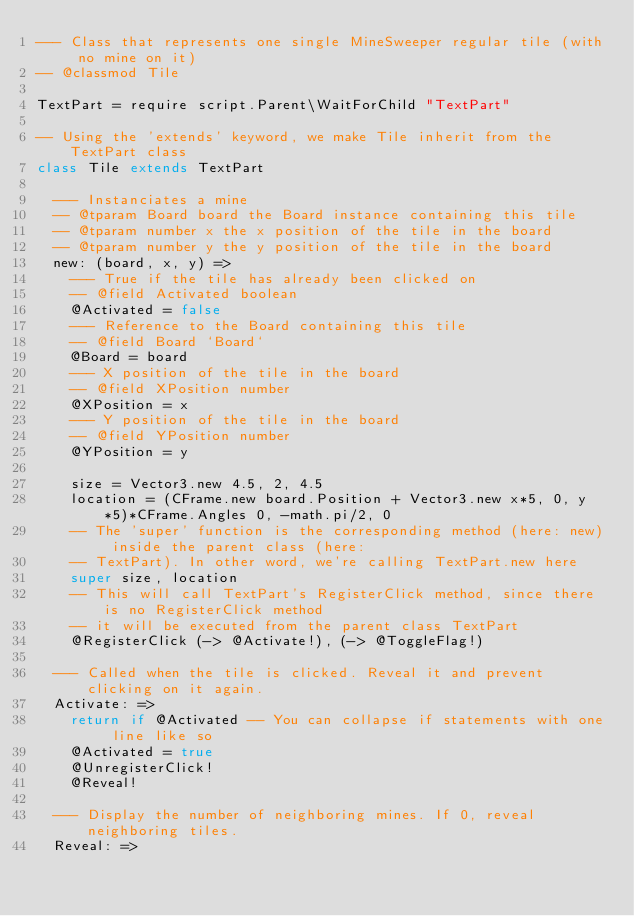<code> <loc_0><loc_0><loc_500><loc_500><_MoonScript_>--- Class that represents one single MineSweeper regular tile (with no mine on it)
-- @classmod Tile

TextPart = require script.Parent\WaitForChild "TextPart"

-- Using the 'extends' keyword, we make Tile inherit from the TextPart class
class Tile extends TextPart

  --- Instanciates a mine
  -- @tparam Board board the Board instance containing this tile
  -- @tparam number x the x position of the tile in the board
  -- @tparam number y the y position of the tile in the board
  new: (board, x, y) =>
    --- True if the tile has already been clicked on
    -- @field Activated boolean
    @Activated = false
    --- Reference to the Board containing this tile
    -- @field Board `Board`
    @Board = board
    --- X position of the tile in the board
    -- @field XPosition number
    @XPosition = x
    --- Y position of the tile in the board
    -- @field YPosition number
    @YPosition = y

    size = Vector3.new 4.5, 2, 4.5
    location = (CFrame.new board.Position + Vector3.new x*5, 0, y*5)*CFrame.Angles 0, -math.pi/2, 0
    -- The 'super' function is the corresponding method (here: new) inside the parent class (here:
    -- TextPart). In other word, we're calling TextPart.new here
    super size, location
    -- This will call TextPart's RegisterClick method, since there is no RegisterClick method
    -- it will be executed from the parent class TextPart
    @RegisterClick (-> @Activate!), (-> @ToggleFlag!)

  --- Called when the tile is clicked. Reveal it and prevent clicking on it again.
  Activate: =>
    return if @Activated -- You can collapse if statements with one line like so
    @Activated = true
    @UnregisterClick!
    @Reveal!

  --- Display the number of neighboring mines. If 0, reveal neighboring tiles.
  Reveal: =></code> 